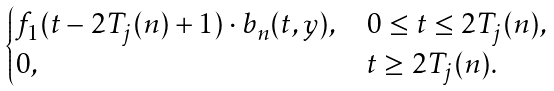Convert formula to latex. <formula><loc_0><loc_0><loc_500><loc_500>\begin{cases} f _ { 1 } ( t - 2 T _ { j } ( n ) + 1 ) \cdot b _ { n } ( t , y ) , & 0 \leq t \leq 2 T _ { j } ( n ) , \\ 0 , & t \geq 2 T _ { j } ( n ) . \end{cases}</formula> 